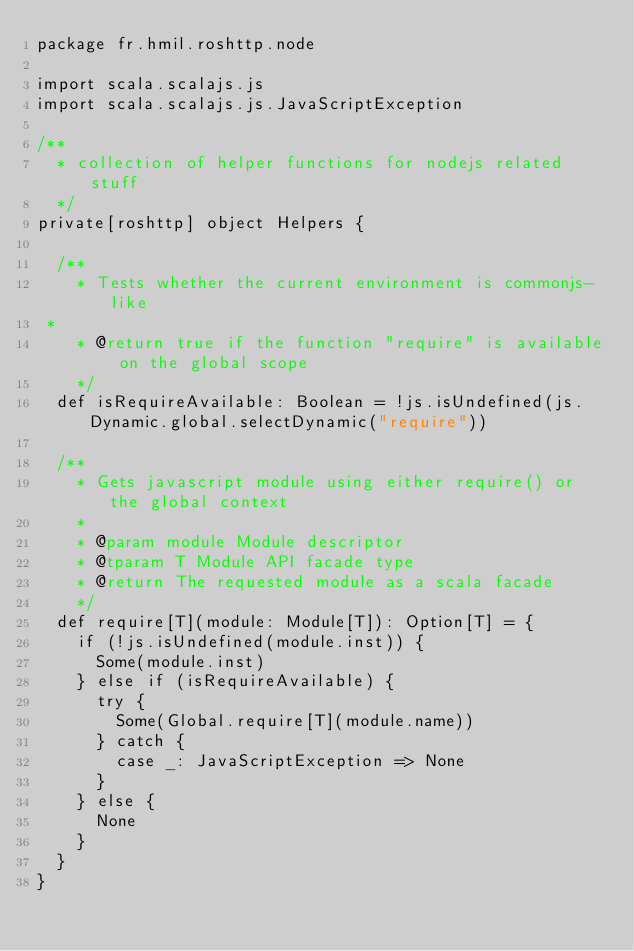Convert code to text. <code><loc_0><loc_0><loc_500><loc_500><_Scala_>package fr.hmil.roshttp.node

import scala.scalajs.js
import scala.scalajs.js.JavaScriptException

/**
  * collection of helper functions for nodejs related stuff
  */
private[roshttp] object Helpers {

  /**
    * Tests whether the current environment is commonjs-like
 *
    * @return true if the function "require" is available on the global scope
    */
  def isRequireAvailable: Boolean = !js.isUndefined(js.Dynamic.global.selectDynamic("require"))

  /**
    * Gets javascript module using either require() or the global context
    *
    * @param module Module descriptor
    * @tparam T Module API facade type
    * @return The requested module as a scala facade
    */
  def require[T](module: Module[T]): Option[T] = {
    if (!js.isUndefined(module.inst)) {
      Some(module.inst)
    } else if (isRequireAvailable) {
      try {
        Some(Global.require[T](module.name))
      } catch {
        case _: JavaScriptException => None
      }
    } else {
      None
    }
  }
}
</code> 